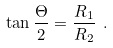<formula> <loc_0><loc_0><loc_500><loc_500>\tan \frac { \Theta } { 2 } = \frac { R _ { 1 } } { R _ { 2 } } \ .</formula> 